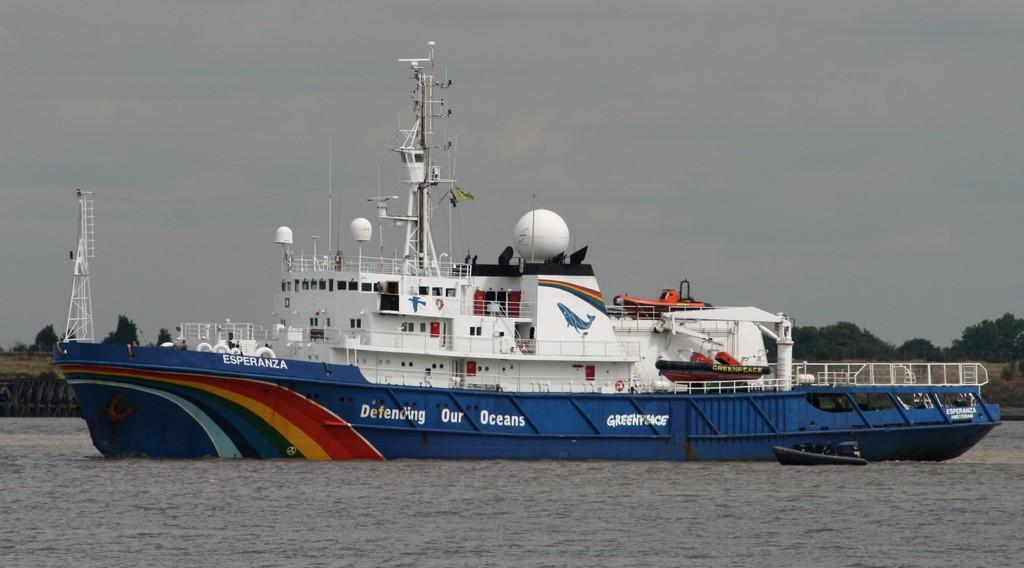<image>
Offer a succinct explanation of the picture presented. A Greenpeace ship with a slogan that says, Defending Our Oceans. 